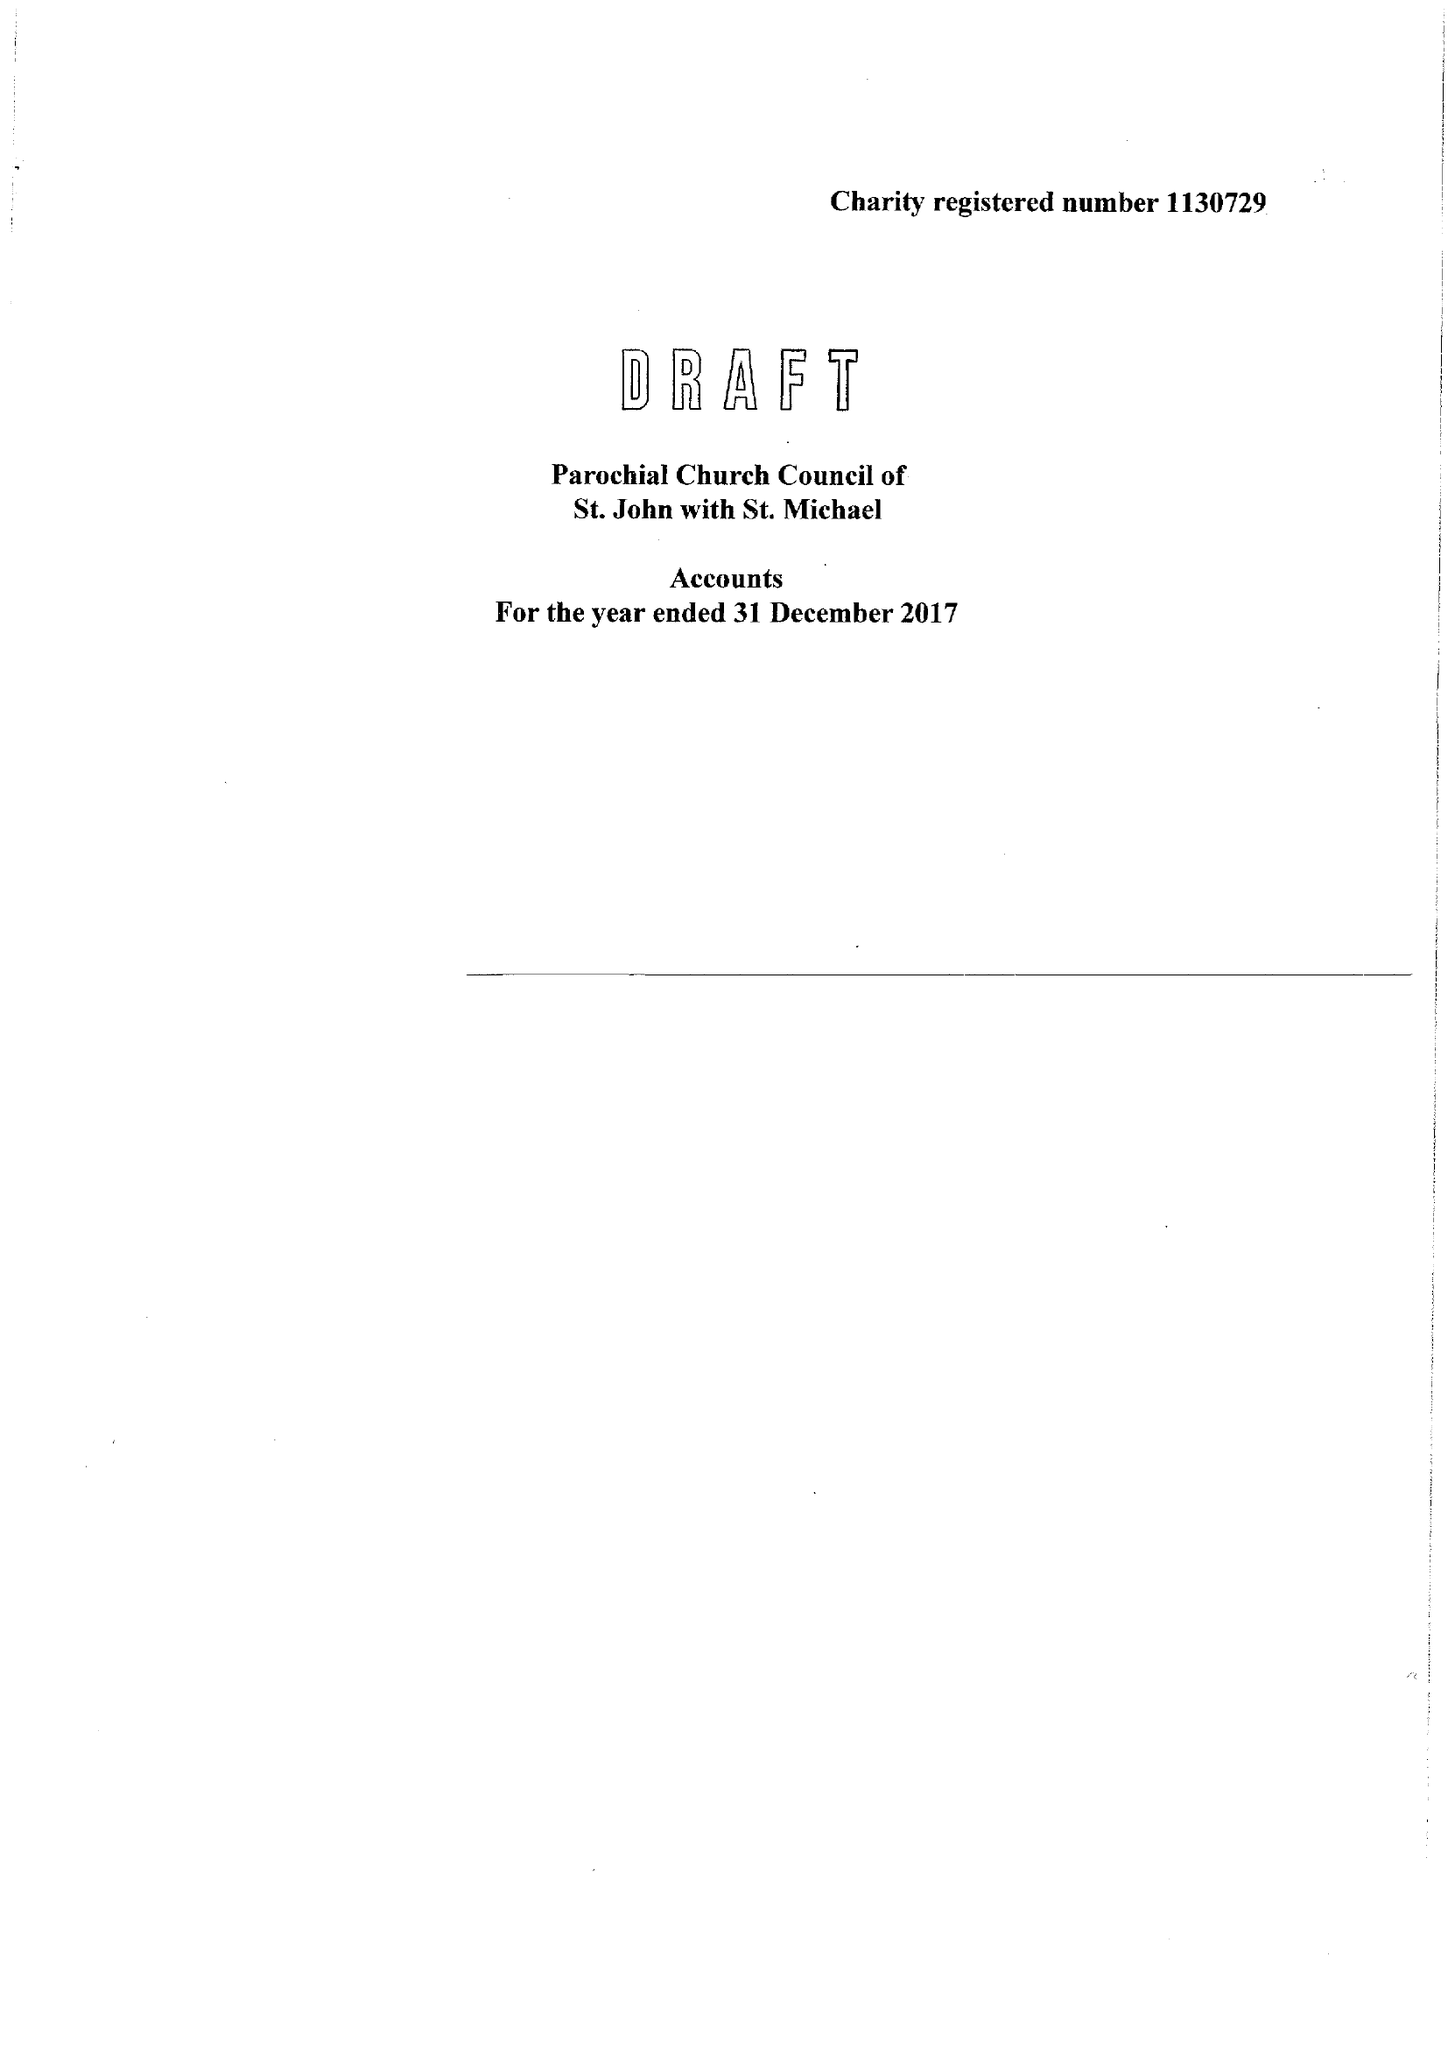What is the value for the report_date?
Answer the question using a single word or phrase. 2017-12-31 